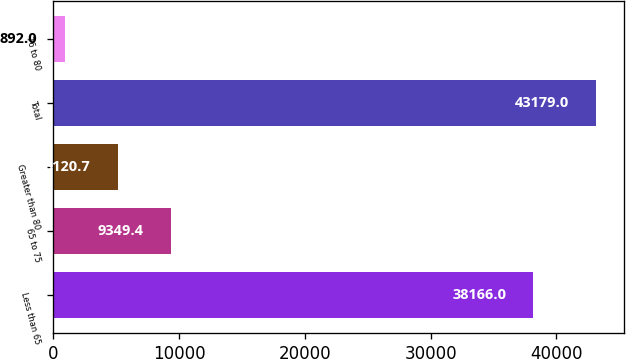<chart> <loc_0><loc_0><loc_500><loc_500><bar_chart><fcel>Less than 65<fcel>65 to 75<fcel>Greater than 80<fcel>Total<fcel>76 to 80<nl><fcel>38166<fcel>9349.4<fcel>5120.7<fcel>43179<fcel>892<nl></chart> 